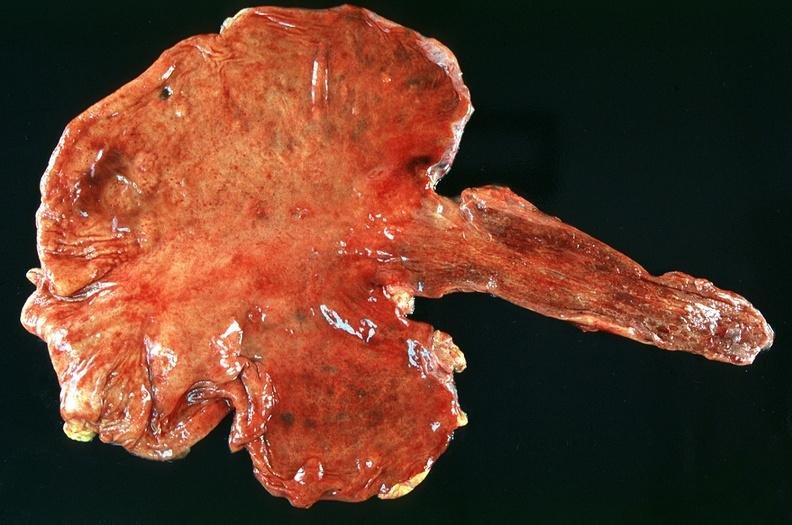where does this belong to?
Answer the question using a single word or phrase. Gastrointestinal system 